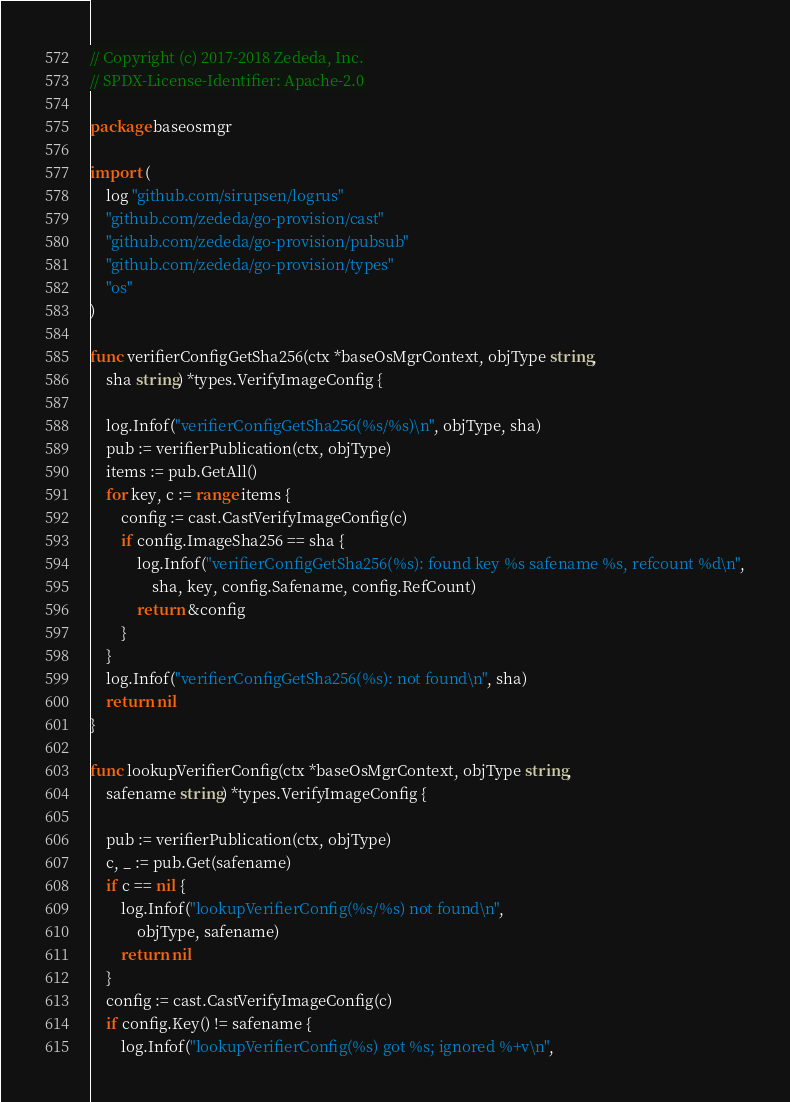<code> <loc_0><loc_0><loc_500><loc_500><_Go_>// Copyright (c) 2017-2018 Zededa, Inc.
// SPDX-License-Identifier: Apache-2.0

package baseosmgr

import (
	log "github.com/sirupsen/logrus"
	"github.com/zededa/go-provision/cast"
	"github.com/zededa/go-provision/pubsub"
	"github.com/zededa/go-provision/types"
	"os"
)

func verifierConfigGetSha256(ctx *baseOsMgrContext, objType string,
	sha string) *types.VerifyImageConfig {

	log.Infof("verifierConfigGetSha256(%s/%s)\n", objType, sha)
	pub := verifierPublication(ctx, objType)
	items := pub.GetAll()
	for key, c := range items {
		config := cast.CastVerifyImageConfig(c)
		if config.ImageSha256 == sha {
			log.Infof("verifierConfigGetSha256(%s): found key %s safename %s, refcount %d\n",
				sha, key, config.Safename, config.RefCount)
			return &config
		}
	}
	log.Infof("verifierConfigGetSha256(%s): not found\n", sha)
	return nil
}

func lookupVerifierConfig(ctx *baseOsMgrContext, objType string,
	safename string) *types.VerifyImageConfig {

	pub := verifierPublication(ctx, objType)
	c, _ := pub.Get(safename)
	if c == nil {
		log.Infof("lookupVerifierConfig(%s/%s) not found\n",
			objType, safename)
		return nil
	}
	config := cast.CastVerifyImageConfig(c)
	if config.Key() != safename {
		log.Infof("lookupVerifierConfig(%s) got %s; ignored %+v\n",</code> 